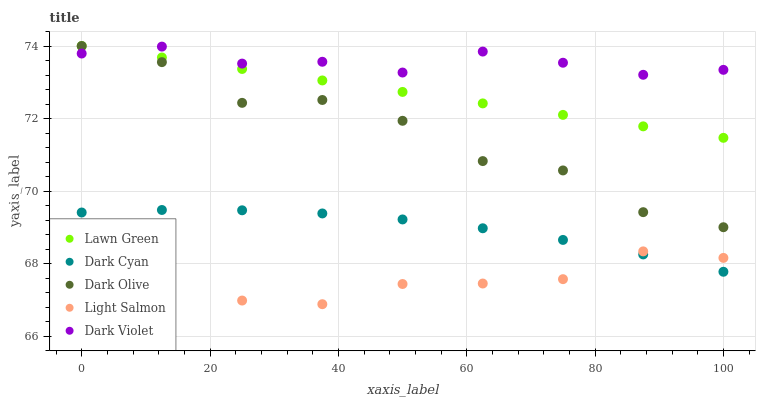Does Light Salmon have the minimum area under the curve?
Answer yes or no. Yes. Does Dark Violet have the maximum area under the curve?
Answer yes or no. Yes. Does Lawn Green have the minimum area under the curve?
Answer yes or no. No. Does Lawn Green have the maximum area under the curve?
Answer yes or no. No. Is Lawn Green the smoothest?
Answer yes or no. Yes. Is Dark Olive the roughest?
Answer yes or no. Yes. Is Light Salmon the smoothest?
Answer yes or no. No. Is Light Salmon the roughest?
Answer yes or no. No. Does Light Salmon have the lowest value?
Answer yes or no. Yes. Does Lawn Green have the lowest value?
Answer yes or no. No. Does Dark Olive have the highest value?
Answer yes or no. Yes. Does Light Salmon have the highest value?
Answer yes or no. No. Is Light Salmon less than Lawn Green?
Answer yes or no. Yes. Is Dark Olive greater than Dark Cyan?
Answer yes or no. Yes. Does Dark Olive intersect Dark Violet?
Answer yes or no. Yes. Is Dark Olive less than Dark Violet?
Answer yes or no. No. Is Dark Olive greater than Dark Violet?
Answer yes or no. No. Does Light Salmon intersect Lawn Green?
Answer yes or no. No. 